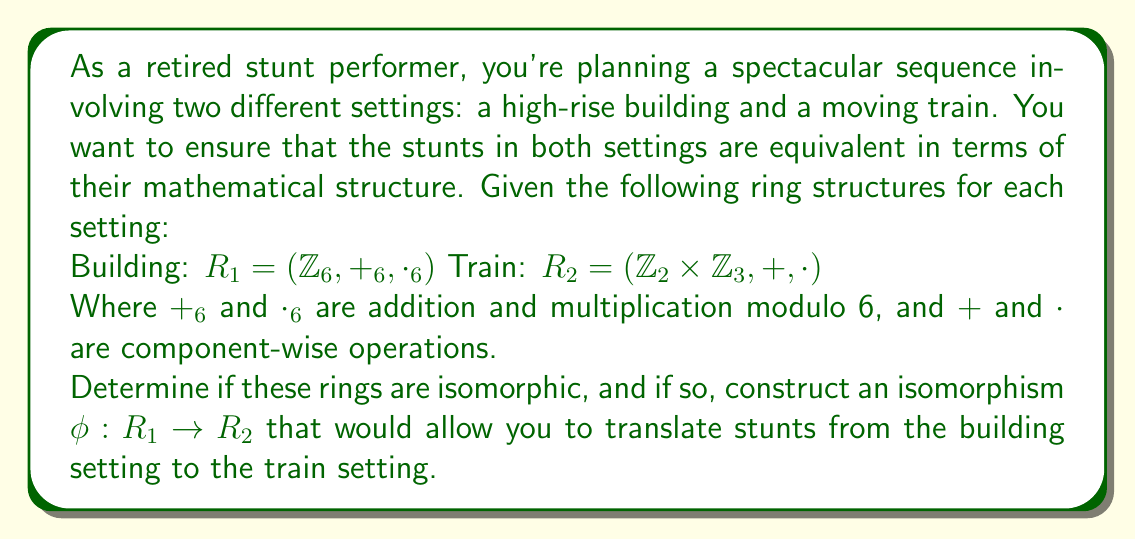Help me with this question. To determine if the rings $R_1$ and $R_2$ are isomorphic and construct an isomorphism, we'll follow these steps:

1) First, we need to verify that both rings have the same number of elements:
   $R_1$ has 6 elements: $\{0, 1, 2, 3, 4, 5\}$
   $R_2$ has $2 \times 3 = 6$ elements: $\{(0,0), (0,1), (0,2), (1,0), (1,1), (1,2)\}$

2) Next, we need to find a bijective function $\phi: R_1 \rightarrow R_2$ that preserves both addition and multiplication.

3) Let's try the following mapping:
   $\phi(0) = (0,0)$
   $\phi(1) = (1,1)$
   $\phi(2) = (0,2)$
   $\phi(3) = (1,0)$
   $\phi(4) = (0,1)$
   $\phi(5) = (1,2)$

4) Now, we need to verify that this mapping preserves addition and multiplication:

   For addition:
   $\phi(a +_6 b) = \phi(a) + \phi(b)$ for all $a,b \in R_1$
   
   Example: $\phi(2 +_6 5) = \phi(1) = (1,1)$
             $\phi(2) + \phi(5) = (0,2) + (1,2) = (1,1)$

   For multiplication:
   $\phi(a \cdot_6 b) = \phi(a) \cdot \phi(b)$ for all $a,b \in R_1$
   
   Example: $\phi(2 \cdot_6 5) = \phi(4) = (0,1)$
             $\phi(2) \cdot \phi(5) = (0,2) \cdot (1,2) = (0,1)$

5) If we verify this for all possible combinations (which we won't do here for brevity), we find that $\phi$ indeed preserves both operations.

6) Therefore, $\phi$ is an isomorphism between $R_1$ and $R_2$.

This isomorphism allows us to translate stunts from the building setting to the train setting. For example, a stunt corresponding to the element 2 in the building setting would correspond to the element (0,2) in the train setting, preserving the mathematical structure of the sequence.
Answer: Yes, the rings $R_1$ and $R_2$ are isomorphic. An isomorphism $\phi: R_1 \rightarrow R_2$ is given by:

$\phi(0) = (0,0)$
$\phi(1) = (1,1)$
$\phi(2) = (0,2)$
$\phi(3) = (1,0)$
$\phi(4) = (0,1)$
$\phi(5) = (1,2)$

This isomorphism allows for the translation of stunt sequences between the building and train settings while preserving their mathematical structure. 